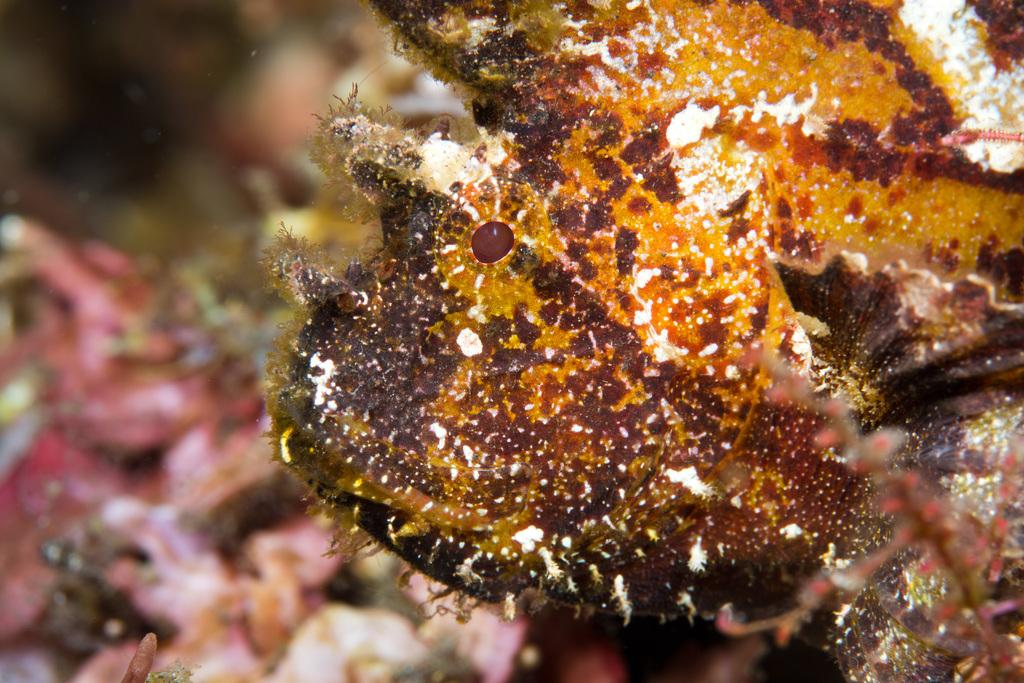What type of creatures can be seen in the image? There are underwater creatures in the image. What type of bed can be seen in the image? There is no bed present in the image; it features underwater creatures. How does the sleet affect the underwater creatures in the image? There is no sleet present in the image, as it is an underwater scene. 